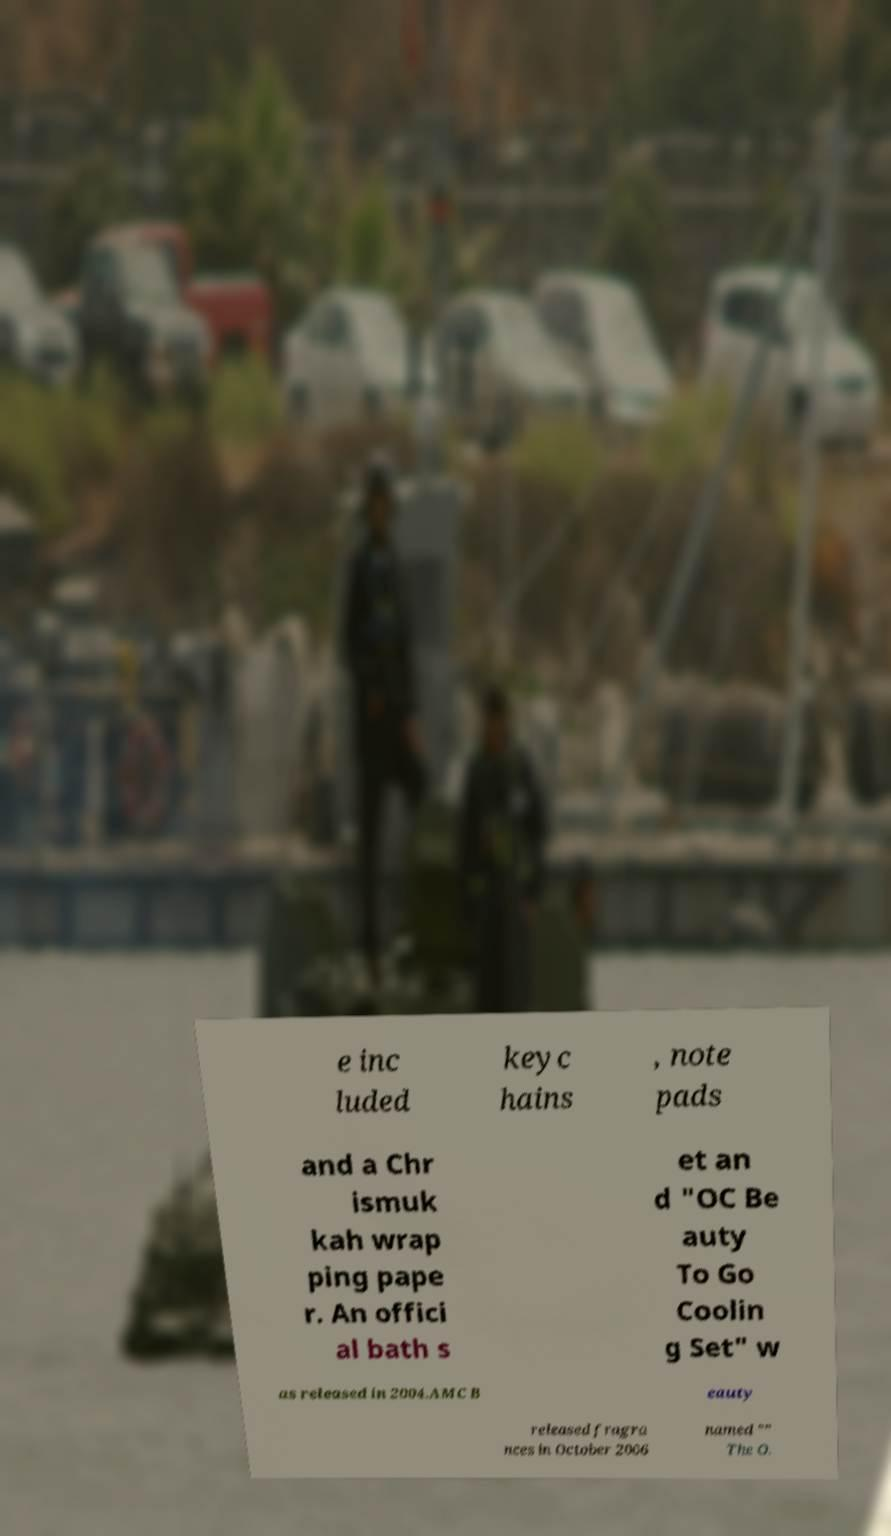Could you assist in decoding the text presented in this image and type it out clearly? e inc luded keyc hains , note pads and a Chr ismuk kah wrap ping pape r. An offici al bath s et an d "OC Be auty To Go Coolin g Set" w as released in 2004.AMC B eauty released fragra nces in October 2006 named "" The O. 